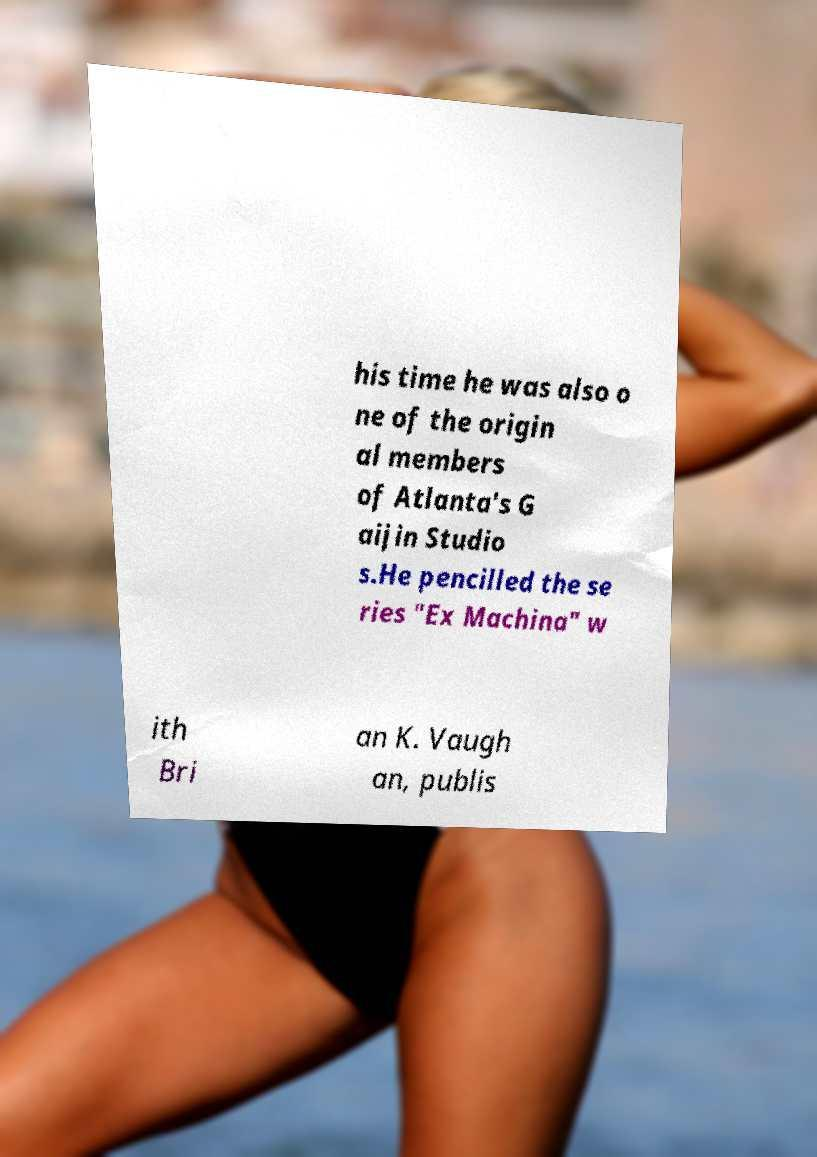Can you accurately transcribe the text from the provided image for me? his time he was also o ne of the origin al members of Atlanta's G aijin Studio s.He pencilled the se ries "Ex Machina" w ith Bri an K. Vaugh an, publis 